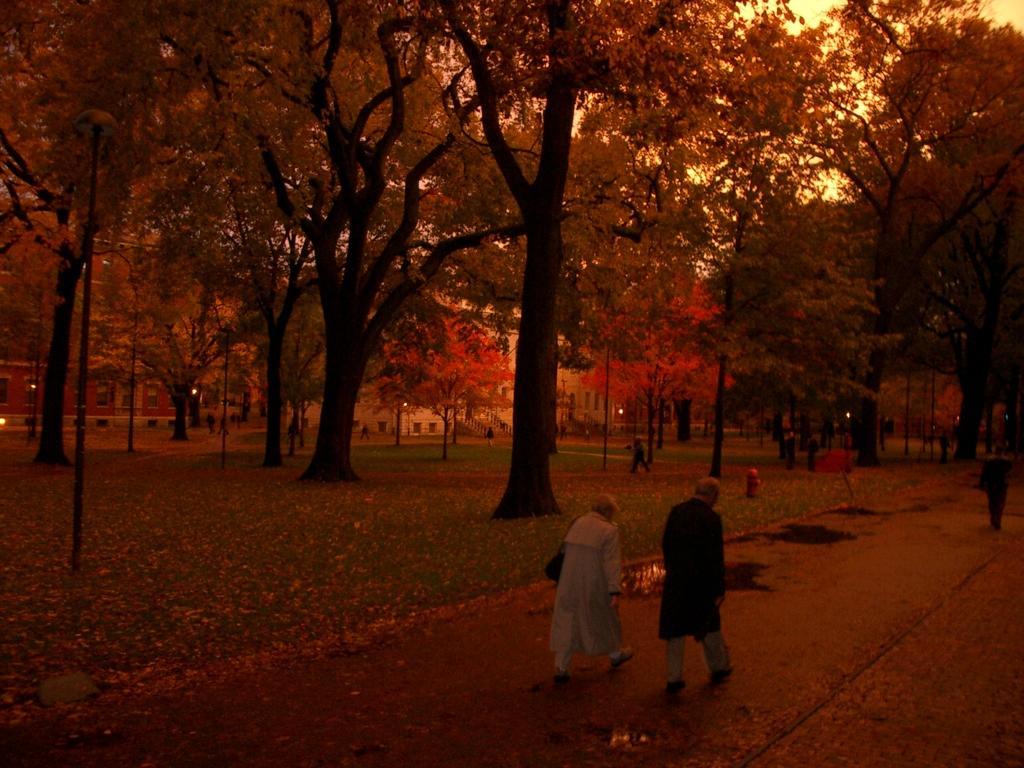How would you summarize this image in a sentence or two? In this image we can see these people walking on the road, we can see muddy water on the road, fire hydrant, grass, trees and the houses in the background. 